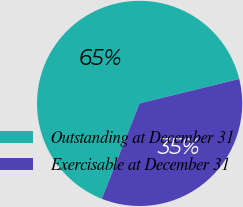Convert chart. <chart><loc_0><loc_0><loc_500><loc_500><pie_chart><fcel>Outstanding at December 31<fcel>Exercisable at December 31<nl><fcel>65.17%<fcel>34.83%<nl></chart> 